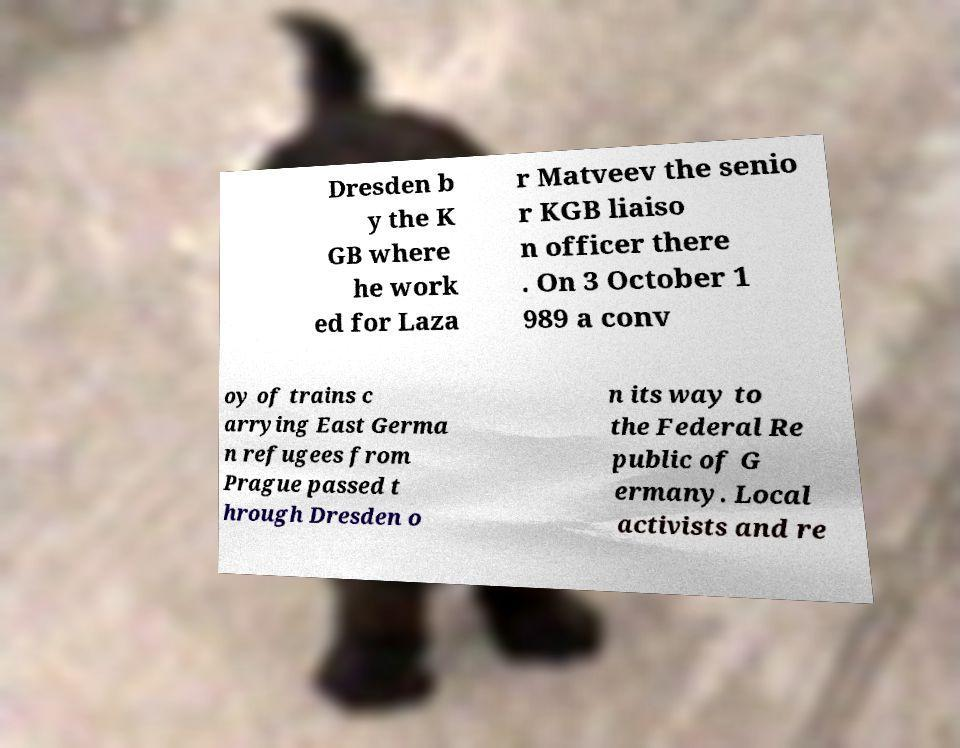For documentation purposes, I need the text within this image transcribed. Could you provide that? Dresden b y the K GB where he work ed for Laza r Matveev the senio r KGB liaiso n officer there . On 3 October 1 989 a conv oy of trains c arrying East Germa n refugees from Prague passed t hrough Dresden o n its way to the Federal Re public of G ermany. Local activists and re 